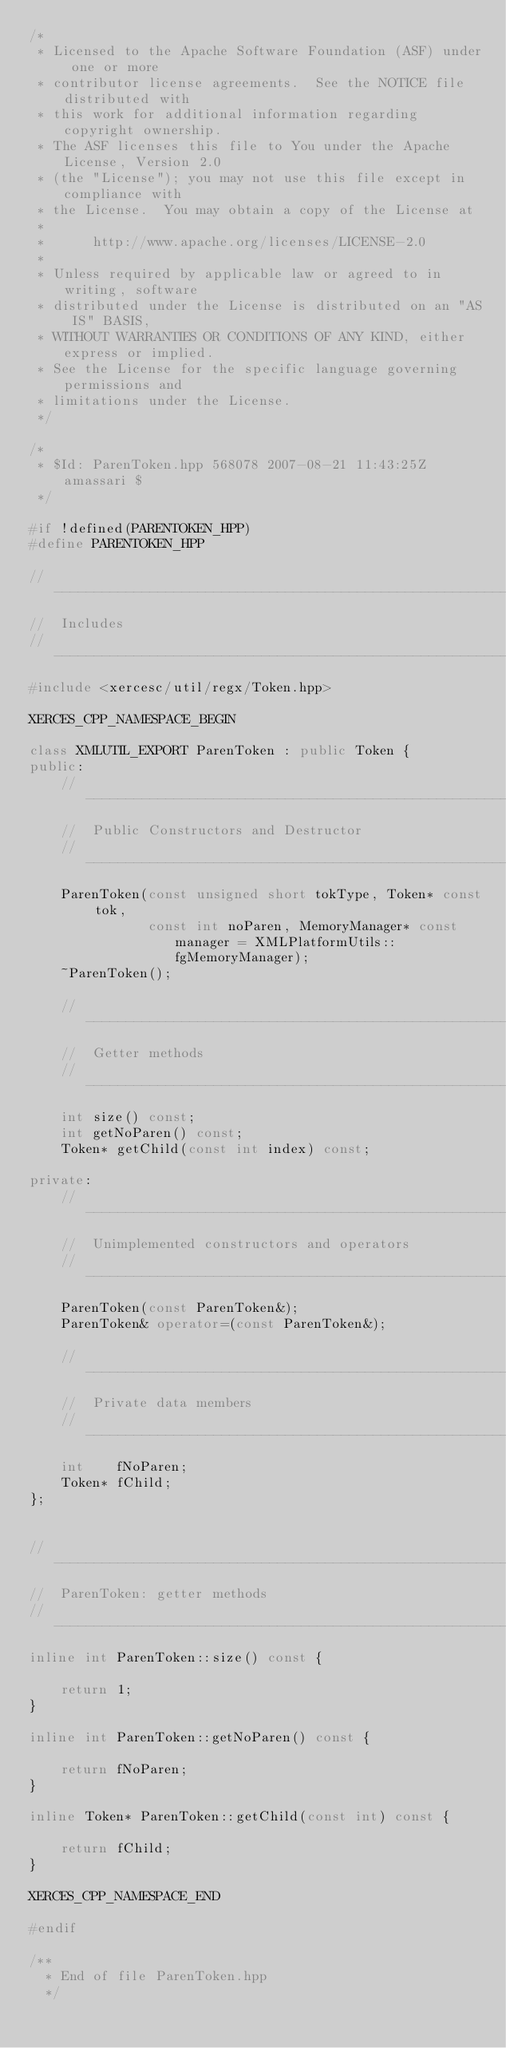<code> <loc_0><loc_0><loc_500><loc_500><_C++_>/*
 * Licensed to the Apache Software Foundation (ASF) under one or more
 * contributor license agreements.  See the NOTICE file distributed with
 * this work for additional information regarding copyright ownership.
 * The ASF licenses this file to You under the Apache License, Version 2.0
 * (the "License"); you may not use this file except in compliance with
 * the License.  You may obtain a copy of the License at
 * 
 *      http://www.apache.org/licenses/LICENSE-2.0
 * 
 * Unless required by applicable law or agreed to in writing, software
 * distributed under the License is distributed on an "AS IS" BASIS,
 * WITHOUT WARRANTIES OR CONDITIONS OF ANY KIND, either express or implied.
 * See the License for the specific language governing permissions and
 * limitations under the License.
 */

/*
 * $Id: ParenToken.hpp 568078 2007-08-21 11:43:25Z amassari $
 */

#if !defined(PARENTOKEN_HPP)
#define PARENTOKEN_HPP

// ---------------------------------------------------------------------------
//  Includes
// ---------------------------------------------------------------------------
#include <xercesc/util/regx/Token.hpp>

XERCES_CPP_NAMESPACE_BEGIN

class XMLUTIL_EXPORT ParenToken : public Token {
public:
	// -----------------------------------------------------------------------
    //  Public Constructors and Destructor
    // -----------------------------------------------------------------------
	ParenToken(const unsigned short tokType, Token* const tok,
               const int noParen, MemoryManager* const manager = XMLPlatformUtils::fgMemoryManager);
    ~ParenToken();

	// -----------------------------------------------------------------------
    //  Getter methods
    // -----------------------------------------------------------------------
    int size() const;
	int getNoParen() const;
    Token* getChild(const int index) const;

private:
	// -----------------------------------------------------------------------
    //  Unimplemented constructors and operators
    // -----------------------------------------------------------------------
    ParenToken(const ParenToken&);
    ParenToken& operator=(const ParenToken&);

	// -----------------------------------------------------------------------
    //  Private data members
	// -----------------------------------------------------------------------
	int    fNoParen;
	Token* fChild;
};


// ---------------------------------------------------------------------------
//  ParenToken: getter methods
// ---------------------------------------------------------------------------
inline int ParenToken::size() const {

    return 1;
}

inline int ParenToken::getNoParen() const {

    return fNoParen;
}

inline Token* ParenToken::getChild(const int) const {

    return fChild;
}

XERCES_CPP_NAMESPACE_END

#endif

/**
  * End of file ParenToken.hpp
  */
</code> 